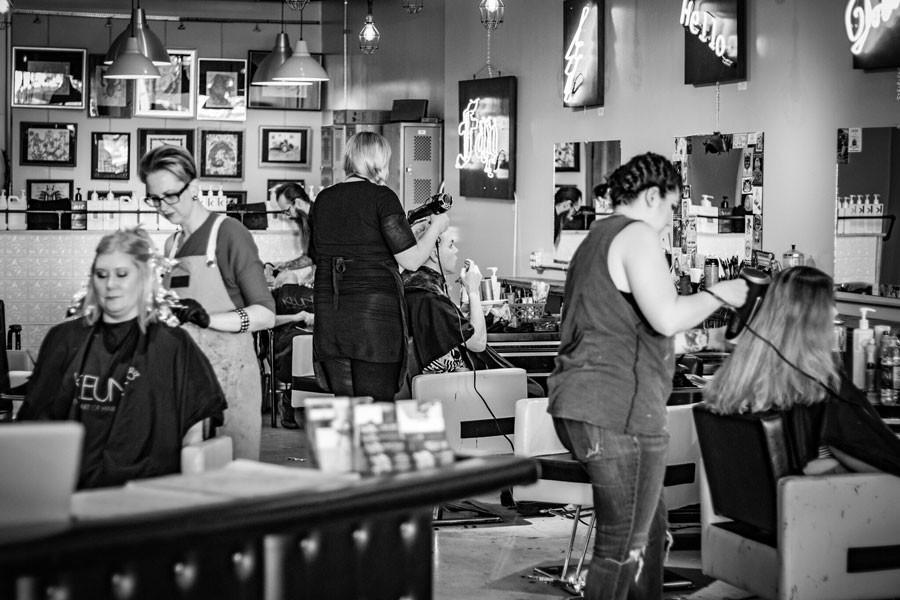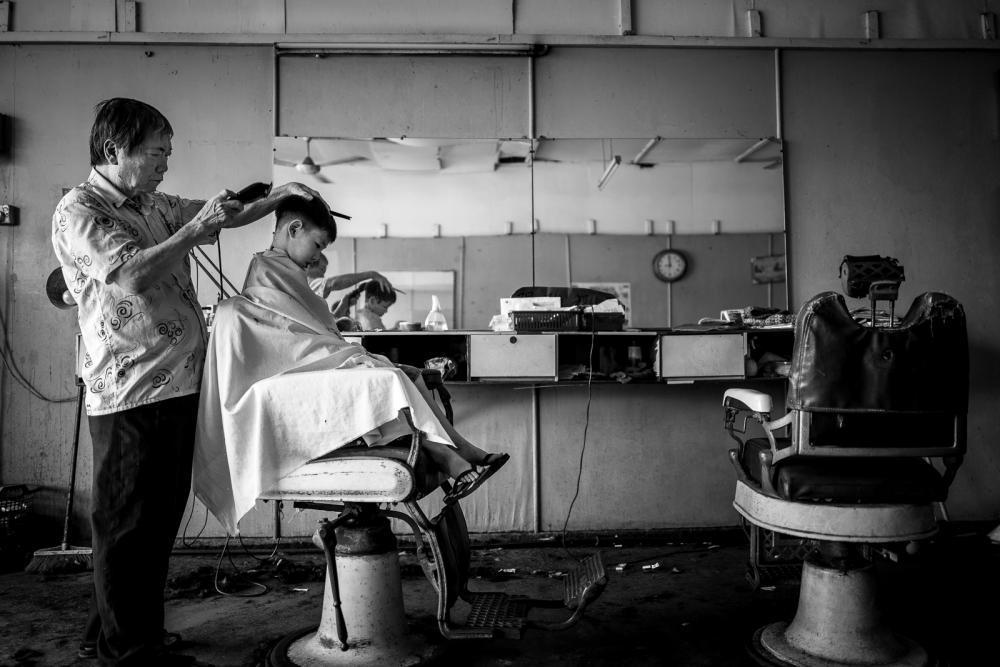The first image is the image on the left, the second image is the image on the right. For the images displayed, is the sentence "The left image includes a man in a hat, glasses and beard standing behind a forward-facing customer in a black smock." factually correct? Answer yes or no. No. The first image is the image on the left, the second image is the image on the right. Considering the images on both sides, is "All of these images are in black and white." valid? Answer yes or no. Yes. 